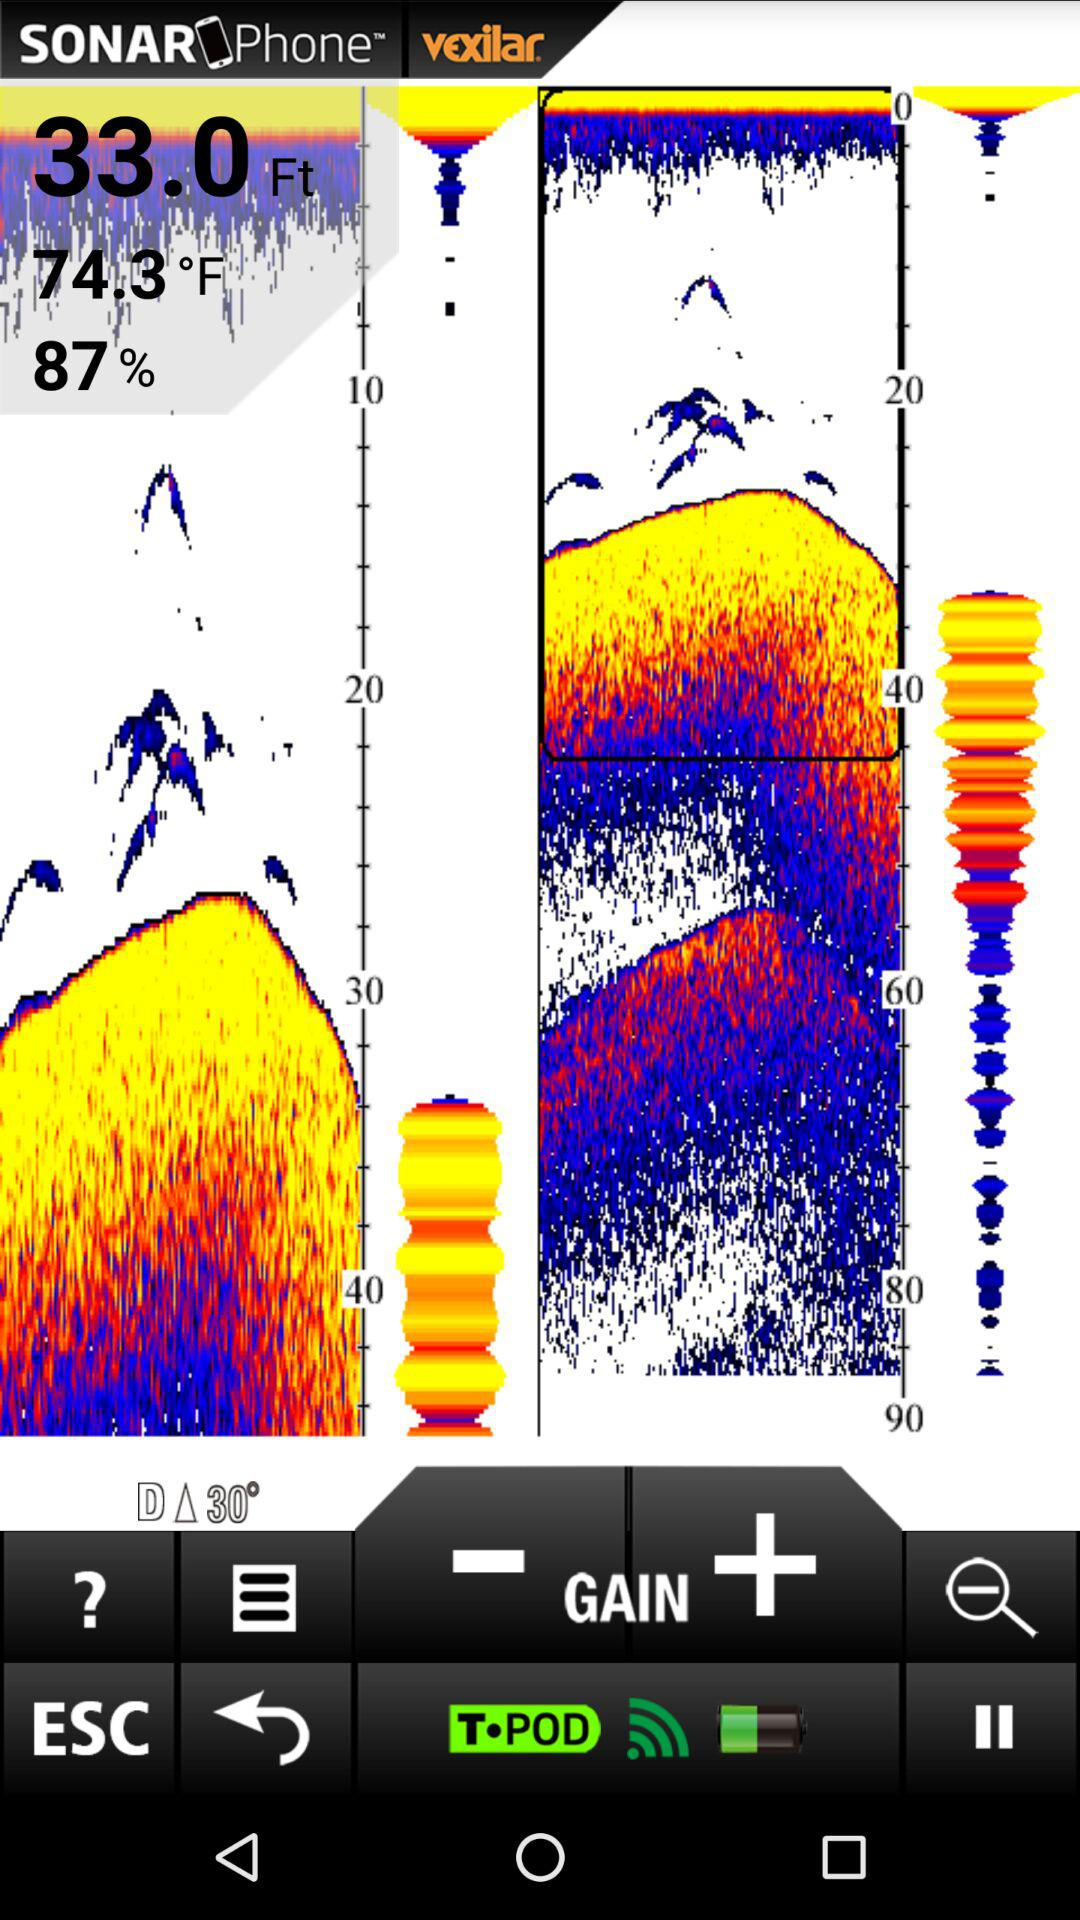What is the temperature? The temperature is 74.3 F. 